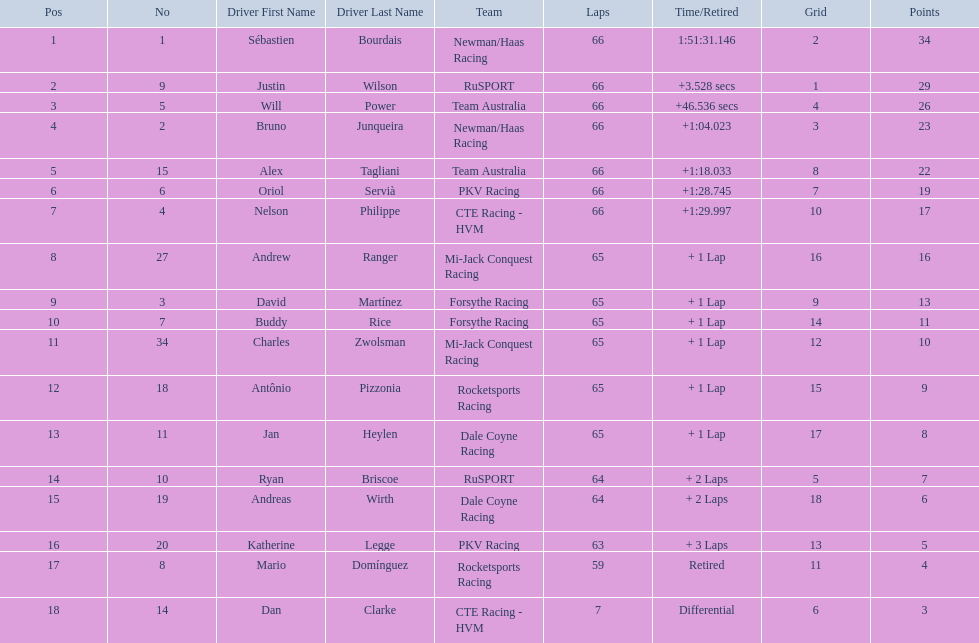What drivers started in the top 10? Sébastien Bourdais, Justin Wilson, Will Power, Bruno Junqueira, Alex Tagliani, Oriol Servià, Nelson Philippe, Ryan Briscoe, Dan Clarke. Which of those drivers completed all 66 laps? Sébastien Bourdais, Justin Wilson, Will Power, Bruno Junqueira, Alex Tagliani, Oriol Servià, Nelson Philippe. Whom of these did not drive for team australia? Sébastien Bourdais, Justin Wilson, Bruno Junqueira, Oriol Servià, Nelson Philippe. Which of these drivers finished more then a minuet after the winner? Bruno Junqueira, Oriol Servià, Nelson Philippe. Which of these drivers had the highest car number? Oriol Servià. 